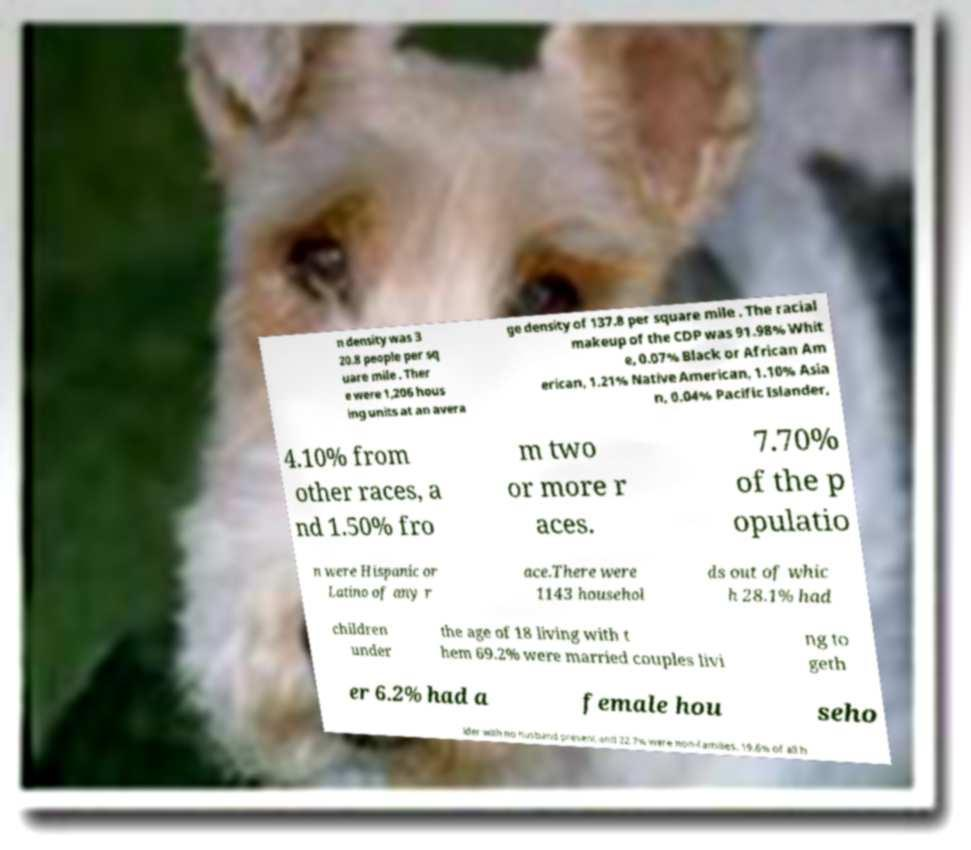Please identify and transcribe the text found in this image. n density was 3 20.8 people per sq uare mile . Ther e were 1,206 hous ing units at an avera ge density of 137.8 per square mile . The racial makeup of the CDP was 91.98% Whit e, 0.07% Black or African Am erican, 1.21% Native American, 1.10% Asia n, 0.04% Pacific Islander, 4.10% from other races, a nd 1.50% fro m two or more r aces. 7.70% of the p opulatio n were Hispanic or Latino of any r ace.There were 1143 househol ds out of whic h 28.1% had children under the age of 18 living with t hem 69.2% were married couples livi ng to geth er 6.2% had a female hou seho lder with no husband present and 22.7% were non-families. 19.6% of all h 